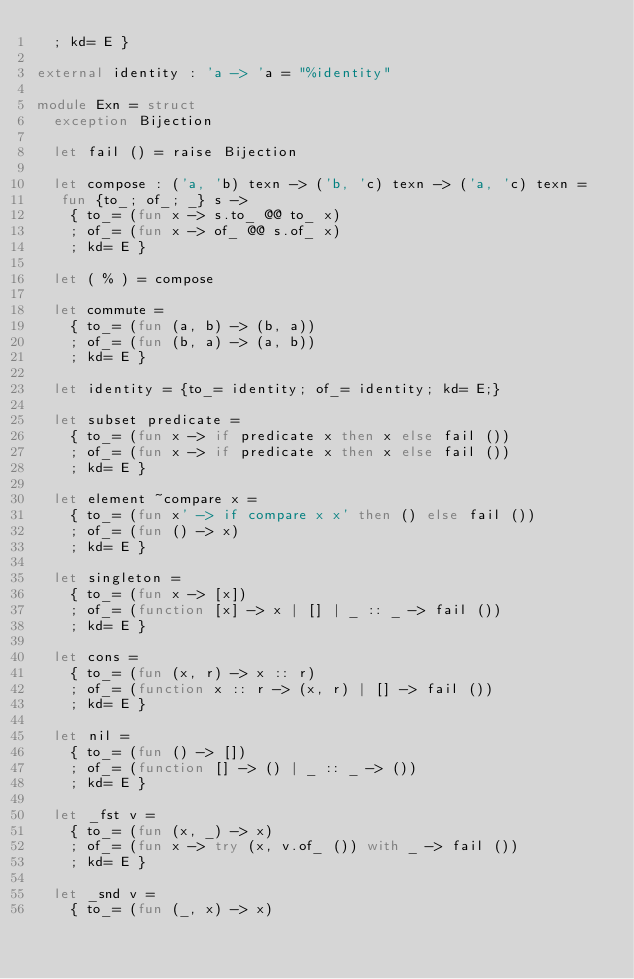Convert code to text. <code><loc_0><loc_0><loc_500><loc_500><_OCaml_>  ; kd= E }

external identity : 'a -> 'a = "%identity"

module Exn = struct
  exception Bijection

  let fail () = raise Bijection

  let compose : ('a, 'b) texn -> ('b, 'c) texn -> ('a, 'c) texn =
   fun {to_; of_; _} s ->
    { to_= (fun x -> s.to_ @@ to_ x)
    ; of_= (fun x -> of_ @@ s.of_ x)
    ; kd= E }

  let ( % ) = compose

  let commute =
    { to_= (fun (a, b) -> (b, a))
    ; of_= (fun (b, a) -> (a, b))
    ; kd= E }

  let identity = {to_= identity; of_= identity; kd= E;}

  let subset predicate =
    { to_= (fun x -> if predicate x then x else fail ())
    ; of_= (fun x -> if predicate x then x else fail ())
    ; kd= E }

  let element ~compare x =
    { to_= (fun x' -> if compare x x' then () else fail ())
    ; of_= (fun () -> x)
    ; kd= E }

  let singleton =
    { to_= (fun x -> [x])
    ; of_= (function [x] -> x | [] | _ :: _ -> fail ())
    ; kd= E }

  let cons =
    { to_= (fun (x, r) -> x :: r)
    ; of_= (function x :: r -> (x, r) | [] -> fail ())
    ; kd= E }

  let nil =
    { to_= (fun () -> [])
    ; of_= (function [] -> () | _ :: _ -> ())
    ; kd= E }

  let _fst v =
    { to_= (fun (x, _) -> x)
    ; of_= (fun x -> try (x, v.of_ ()) with _ -> fail ())
    ; kd= E }

  let _snd v =
    { to_= (fun (_, x) -> x)</code> 